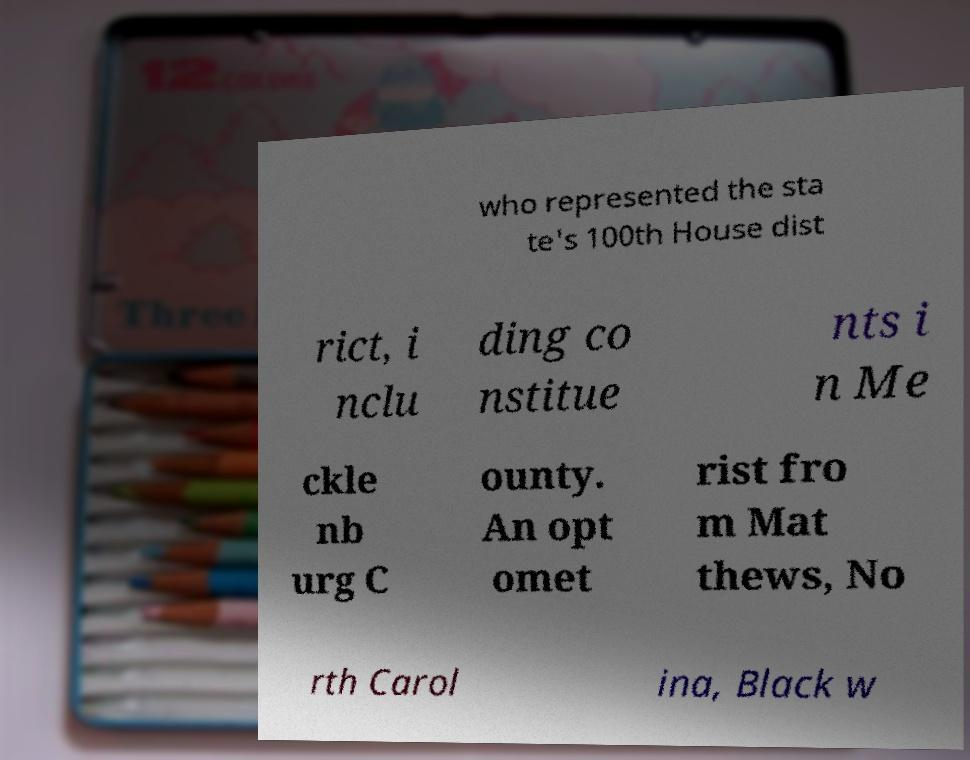Please identify and transcribe the text found in this image. who represented the sta te's 100th House dist rict, i nclu ding co nstitue nts i n Me ckle nb urg C ounty. An opt omet rist fro m Mat thews, No rth Carol ina, Black w 